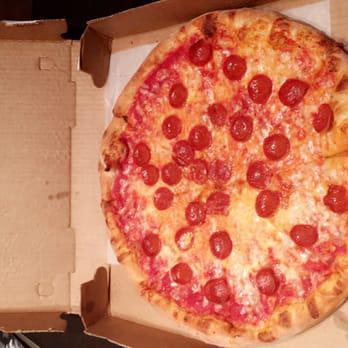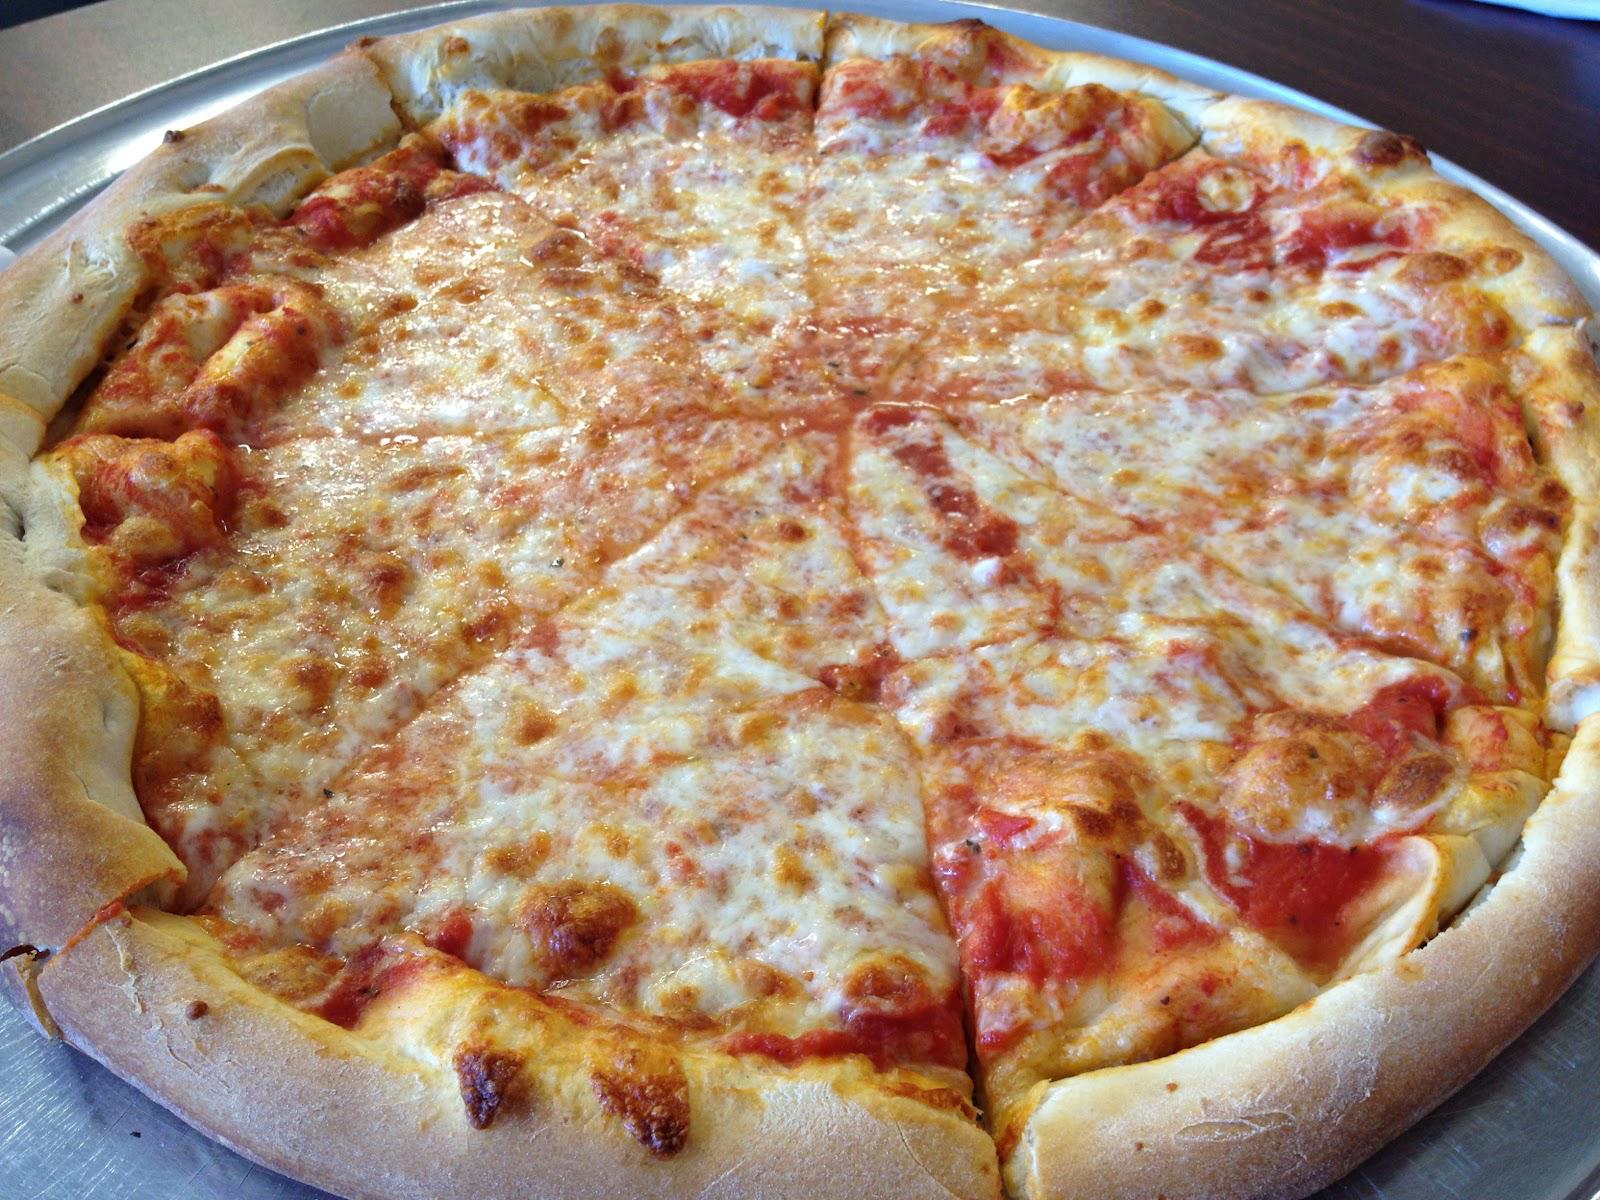The first image is the image on the left, the second image is the image on the right. Analyze the images presented: Is the assertion "One image shows a complete round pizza, and the other image features at least one pizza slice on a white paper plate." valid? Answer yes or no. No. The first image is the image on the left, the second image is the image on the right. For the images shown, is this caption "There is pizza on a paper plate." true? Answer yes or no. No. 